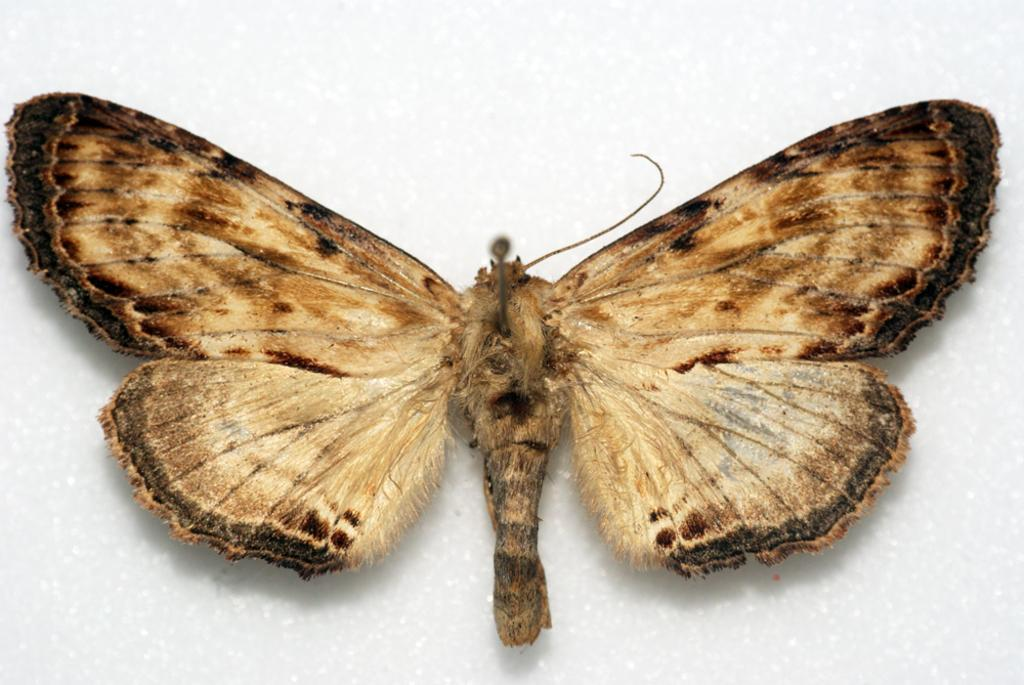What is the main subject of the image? The main subject of the image is a butterfly. What is the color of the surface the butterfly is on? The butterfly is on a white surface. What type of laborer is working in the background of the image? There is no laborer present in the image; it only features a butterfly on a white surface. How many hands can be seen interacting with the butterfly in the image? There are no hands visible in the image, as the butterfly is on a white surface without any interaction. 